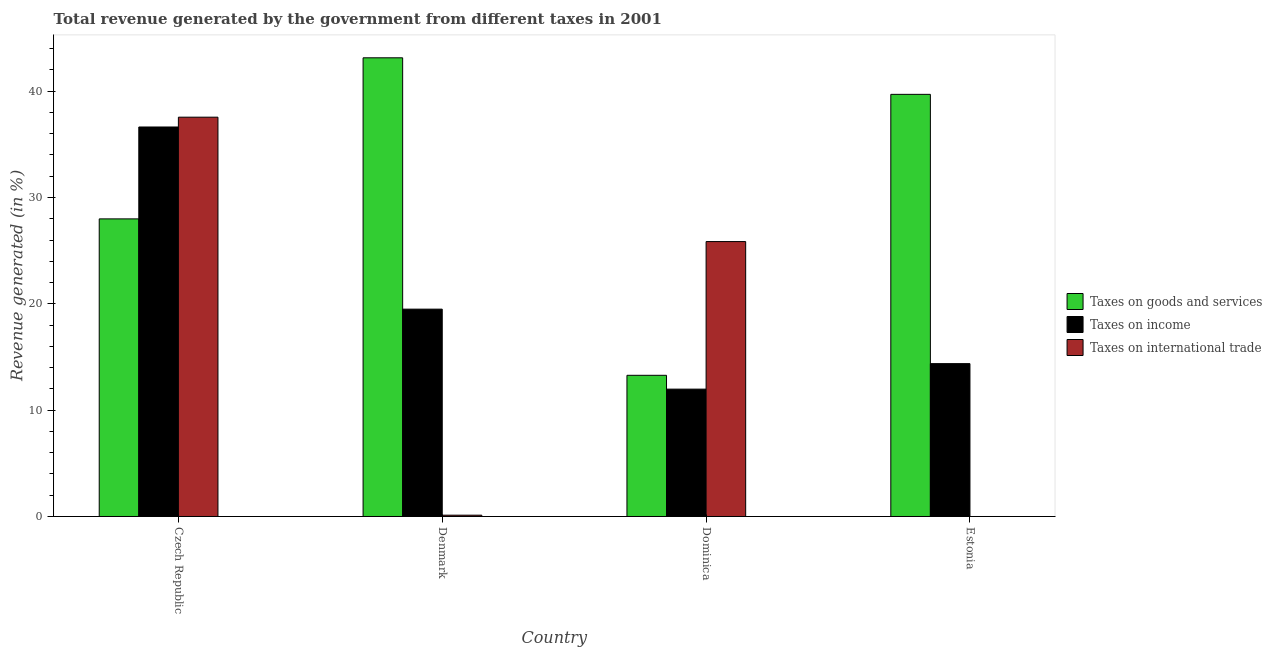How many different coloured bars are there?
Provide a succinct answer. 3. Are the number of bars per tick equal to the number of legend labels?
Offer a terse response. No. Are the number of bars on each tick of the X-axis equal?
Provide a short and direct response. No. How many bars are there on the 1st tick from the left?
Ensure brevity in your answer.  3. How many bars are there on the 4th tick from the right?
Provide a succinct answer. 3. What is the label of the 1st group of bars from the left?
Keep it short and to the point. Czech Republic. What is the percentage of revenue generated by tax on international trade in Denmark?
Ensure brevity in your answer.  0.12. Across all countries, what is the maximum percentage of revenue generated by taxes on income?
Make the answer very short. 36.63. Across all countries, what is the minimum percentage of revenue generated by taxes on income?
Offer a very short reply. 11.98. In which country was the percentage of revenue generated by taxes on goods and services maximum?
Provide a short and direct response. Denmark. What is the total percentage of revenue generated by taxes on goods and services in the graph?
Ensure brevity in your answer.  124.11. What is the difference between the percentage of revenue generated by taxes on goods and services in Denmark and that in Dominica?
Offer a terse response. 29.86. What is the difference between the percentage of revenue generated by taxes on income in Estonia and the percentage of revenue generated by tax on international trade in Dominica?
Keep it short and to the point. -11.48. What is the average percentage of revenue generated by taxes on goods and services per country?
Give a very brief answer. 31.03. What is the difference between the percentage of revenue generated by taxes on income and percentage of revenue generated by tax on international trade in Denmark?
Ensure brevity in your answer.  19.38. In how many countries, is the percentage of revenue generated by tax on international trade greater than 8 %?
Your response must be concise. 2. What is the ratio of the percentage of revenue generated by taxes on goods and services in Czech Republic to that in Denmark?
Make the answer very short. 0.65. Is the percentage of revenue generated by taxes on income in Denmark less than that in Dominica?
Provide a short and direct response. No. Is the difference between the percentage of revenue generated by taxes on goods and services in Czech Republic and Dominica greater than the difference between the percentage of revenue generated by taxes on income in Czech Republic and Dominica?
Your answer should be compact. No. What is the difference between the highest and the second highest percentage of revenue generated by tax on international trade?
Ensure brevity in your answer.  11.7. What is the difference between the highest and the lowest percentage of revenue generated by taxes on income?
Provide a succinct answer. 24.65. Is it the case that in every country, the sum of the percentage of revenue generated by taxes on goods and services and percentage of revenue generated by taxes on income is greater than the percentage of revenue generated by tax on international trade?
Your response must be concise. No. How many bars are there?
Your answer should be compact. 11. What is the difference between two consecutive major ticks on the Y-axis?
Provide a succinct answer. 10. What is the title of the graph?
Provide a short and direct response. Total revenue generated by the government from different taxes in 2001. What is the label or title of the X-axis?
Offer a very short reply. Country. What is the label or title of the Y-axis?
Offer a very short reply. Revenue generated (in %). What is the Revenue generated (in %) in Taxes on goods and services in Czech Republic?
Provide a short and direct response. 27.99. What is the Revenue generated (in %) in Taxes on income in Czech Republic?
Ensure brevity in your answer.  36.63. What is the Revenue generated (in %) in Taxes on international trade in Czech Republic?
Make the answer very short. 37.55. What is the Revenue generated (in %) of Taxes on goods and services in Denmark?
Offer a terse response. 43.14. What is the Revenue generated (in %) in Taxes on income in Denmark?
Offer a very short reply. 19.5. What is the Revenue generated (in %) of Taxes on international trade in Denmark?
Give a very brief answer. 0.12. What is the Revenue generated (in %) in Taxes on goods and services in Dominica?
Make the answer very short. 13.28. What is the Revenue generated (in %) in Taxes on income in Dominica?
Make the answer very short. 11.98. What is the Revenue generated (in %) of Taxes on international trade in Dominica?
Keep it short and to the point. 25.86. What is the Revenue generated (in %) in Taxes on goods and services in Estonia?
Ensure brevity in your answer.  39.7. What is the Revenue generated (in %) in Taxes on income in Estonia?
Make the answer very short. 14.38. Across all countries, what is the maximum Revenue generated (in %) of Taxes on goods and services?
Make the answer very short. 43.14. Across all countries, what is the maximum Revenue generated (in %) in Taxes on income?
Give a very brief answer. 36.63. Across all countries, what is the maximum Revenue generated (in %) of Taxes on international trade?
Your answer should be very brief. 37.55. Across all countries, what is the minimum Revenue generated (in %) of Taxes on goods and services?
Your answer should be very brief. 13.28. Across all countries, what is the minimum Revenue generated (in %) of Taxes on income?
Make the answer very short. 11.98. What is the total Revenue generated (in %) of Taxes on goods and services in the graph?
Give a very brief answer. 124.11. What is the total Revenue generated (in %) in Taxes on income in the graph?
Keep it short and to the point. 82.49. What is the total Revenue generated (in %) of Taxes on international trade in the graph?
Your response must be concise. 63.53. What is the difference between the Revenue generated (in %) in Taxes on goods and services in Czech Republic and that in Denmark?
Ensure brevity in your answer.  -15.15. What is the difference between the Revenue generated (in %) of Taxes on income in Czech Republic and that in Denmark?
Your response must be concise. 17.13. What is the difference between the Revenue generated (in %) of Taxes on international trade in Czech Republic and that in Denmark?
Your response must be concise. 37.43. What is the difference between the Revenue generated (in %) in Taxes on goods and services in Czech Republic and that in Dominica?
Offer a very short reply. 14.71. What is the difference between the Revenue generated (in %) of Taxes on income in Czech Republic and that in Dominica?
Provide a short and direct response. 24.65. What is the difference between the Revenue generated (in %) of Taxes on international trade in Czech Republic and that in Dominica?
Keep it short and to the point. 11.7. What is the difference between the Revenue generated (in %) of Taxes on goods and services in Czech Republic and that in Estonia?
Make the answer very short. -11.71. What is the difference between the Revenue generated (in %) of Taxes on income in Czech Republic and that in Estonia?
Your answer should be very brief. 22.26. What is the difference between the Revenue generated (in %) of Taxes on goods and services in Denmark and that in Dominica?
Your response must be concise. 29.86. What is the difference between the Revenue generated (in %) of Taxes on income in Denmark and that in Dominica?
Your response must be concise. 7.52. What is the difference between the Revenue generated (in %) in Taxes on international trade in Denmark and that in Dominica?
Your response must be concise. -25.73. What is the difference between the Revenue generated (in %) in Taxes on goods and services in Denmark and that in Estonia?
Ensure brevity in your answer.  3.44. What is the difference between the Revenue generated (in %) of Taxes on income in Denmark and that in Estonia?
Your answer should be compact. 5.12. What is the difference between the Revenue generated (in %) in Taxes on goods and services in Dominica and that in Estonia?
Keep it short and to the point. -26.42. What is the difference between the Revenue generated (in %) in Taxes on income in Dominica and that in Estonia?
Your answer should be compact. -2.4. What is the difference between the Revenue generated (in %) of Taxes on goods and services in Czech Republic and the Revenue generated (in %) of Taxes on income in Denmark?
Offer a very short reply. 8.49. What is the difference between the Revenue generated (in %) of Taxes on goods and services in Czech Republic and the Revenue generated (in %) of Taxes on international trade in Denmark?
Provide a succinct answer. 27.87. What is the difference between the Revenue generated (in %) in Taxes on income in Czech Republic and the Revenue generated (in %) in Taxes on international trade in Denmark?
Provide a succinct answer. 36.51. What is the difference between the Revenue generated (in %) of Taxes on goods and services in Czech Republic and the Revenue generated (in %) of Taxes on income in Dominica?
Your response must be concise. 16.01. What is the difference between the Revenue generated (in %) in Taxes on goods and services in Czech Republic and the Revenue generated (in %) in Taxes on international trade in Dominica?
Provide a succinct answer. 2.13. What is the difference between the Revenue generated (in %) in Taxes on income in Czech Republic and the Revenue generated (in %) in Taxes on international trade in Dominica?
Ensure brevity in your answer.  10.78. What is the difference between the Revenue generated (in %) of Taxes on goods and services in Czech Republic and the Revenue generated (in %) of Taxes on income in Estonia?
Make the answer very short. 13.61. What is the difference between the Revenue generated (in %) of Taxes on goods and services in Denmark and the Revenue generated (in %) of Taxes on income in Dominica?
Make the answer very short. 31.16. What is the difference between the Revenue generated (in %) in Taxes on goods and services in Denmark and the Revenue generated (in %) in Taxes on international trade in Dominica?
Your answer should be compact. 17.28. What is the difference between the Revenue generated (in %) of Taxes on income in Denmark and the Revenue generated (in %) of Taxes on international trade in Dominica?
Offer a very short reply. -6.35. What is the difference between the Revenue generated (in %) of Taxes on goods and services in Denmark and the Revenue generated (in %) of Taxes on income in Estonia?
Your answer should be compact. 28.76. What is the difference between the Revenue generated (in %) of Taxes on goods and services in Dominica and the Revenue generated (in %) of Taxes on income in Estonia?
Your answer should be compact. -1.1. What is the average Revenue generated (in %) in Taxes on goods and services per country?
Your answer should be compact. 31.03. What is the average Revenue generated (in %) of Taxes on income per country?
Provide a succinct answer. 20.62. What is the average Revenue generated (in %) in Taxes on international trade per country?
Provide a short and direct response. 15.88. What is the difference between the Revenue generated (in %) of Taxes on goods and services and Revenue generated (in %) of Taxes on income in Czech Republic?
Ensure brevity in your answer.  -8.64. What is the difference between the Revenue generated (in %) in Taxes on goods and services and Revenue generated (in %) in Taxes on international trade in Czech Republic?
Ensure brevity in your answer.  -9.57. What is the difference between the Revenue generated (in %) of Taxes on income and Revenue generated (in %) of Taxes on international trade in Czech Republic?
Your response must be concise. -0.92. What is the difference between the Revenue generated (in %) of Taxes on goods and services and Revenue generated (in %) of Taxes on income in Denmark?
Offer a very short reply. 23.64. What is the difference between the Revenue generated (in %) of Taxes on goods and services and Revenue generated (in %) of Taxes on international trade in Denmark?
Keep it short and to the point. 43.02. What is the difference between the Revenue generated (in %) of Taxes on income and Revenue generated (in %) of Taxes on international trade in Denmark?
Provide a short and direct response. 19.38. What is the difference between the Revenue generated (in %) in Taxes on goods and services and Revenue generated (in %) in Taxes on income in Dominica?
Provide a short and direct response. 1.3. What is the difference between the Revenue generated (in %) in Taxes on goods and services and Revenue generated (in %) in Taxes on international trade in Dominica?
Give a very brief answer. -12.58. What is the difference between the Revenue generated (in %) in Taxes on income and Revenue generated (in %) in Taxes on international trade in Dominica?
Offer a very short reply. -13.88. What is the difference between the Revenue generated (in %) in Taxes on goods and services and Revenue generated (in %) in Taxes on income in Estonia?
Offer a terse response. 25.33. What is the ratio of the Revenue generated (in %) in Taxes on goods and services in Czech Republic to that in Denmark?
Provide a succinct answer. 0.65. What is the ratio of the Revenue generated (in %) in Taxes on income in Czech Republic to that in Denmark?
Your answer should be compact. 1.88. What is the ratio of the Revenue generated (in %) in Taxes on international trade in Czech Republic to that in Denmark?
Make the answer very short. 305.69. What is the ratio of the Revenue generated (in %) of Taxes on goods and services in Czech Republic to that in Dominica?
Provide a succinct answer. 2.11. What is the ratio of the Revenue generated (in %) of Taxes on income in Czech Republic to that in Dominica?
Provide a short and direct response. 3.06. What is the ratio of the Revenue generated (in %) of Taxes on international trade in Czech Republic to that in Dominica?
Offer a very short reply. 1.45. What is the ratio of the Revenue generated (in %) of Taxes on goods and services in Czech Republic to that in Estonia?
Offer a terse response. 0.7. What is the ratio of the Revenue generated (in %) in Taxes on income in Czech Republic to that in Estonia?
Ensure brevity in your answer.  2.55. What is the ratio of the Revenue generated (in %) in Taxes on goods and services in Denmark to that in Dominica?
Provide a succinct answer. 3.25. What is the ratio of the Revenue generated (in %) in Taxes on income in Denmark to that in Dominica?
Give a very brief answer. 1.63. What is the ratio of the Revenue generated (in %) of Taxes on international trade in Denmark to that in Dominica?
Give a very brief answer. 0. What is the ratio of the Revenue generated (in %) in Taxes on goods and services in Denmark to that in Estonia?
Give a very brief answer. 1.09. What is the ratio of the Revenue generated (in %) in Taxes on income in Denmark to that in Estonia?
Offer a terse response. 1.36. What is the ratio of the Revenue generated (in %) of Taxes on goods and services in Dominica to that in Estonia?
Provide a short and direct response. 0.33. What is the ratio of the Revenue generated (in %) in Taxes on income in Dominica to that in Estonia?
Your answer should be very brief. 0.83. What is the difference between the highest and the second highest Revenue generated (in %) of Taxes on goods and services?
Offer a terse response. 3.44. What is the difference between the highest and the second highest Revenue generated (in %) in Taxes on income?
Give a very brief answer. 17.13. What is the difference between the highest and the second highest Revenue generated (in %) in Taxes on international trade?
Give a very brief answer. 11.7. What is the difference between the highest and the lowest Revenue generated (in %) in Taxes on goods and services?
Ensure brevity in your answer.  29.86. What is the difference between the highest and the lowest Revenue generated (in %) of Taxes on income?
Provide a succinct answer. 24.65. What is the difference between the highest and the lowest Revenue generated (in %) in Taxes on international trade?
Your response must be concise. 37.55. 